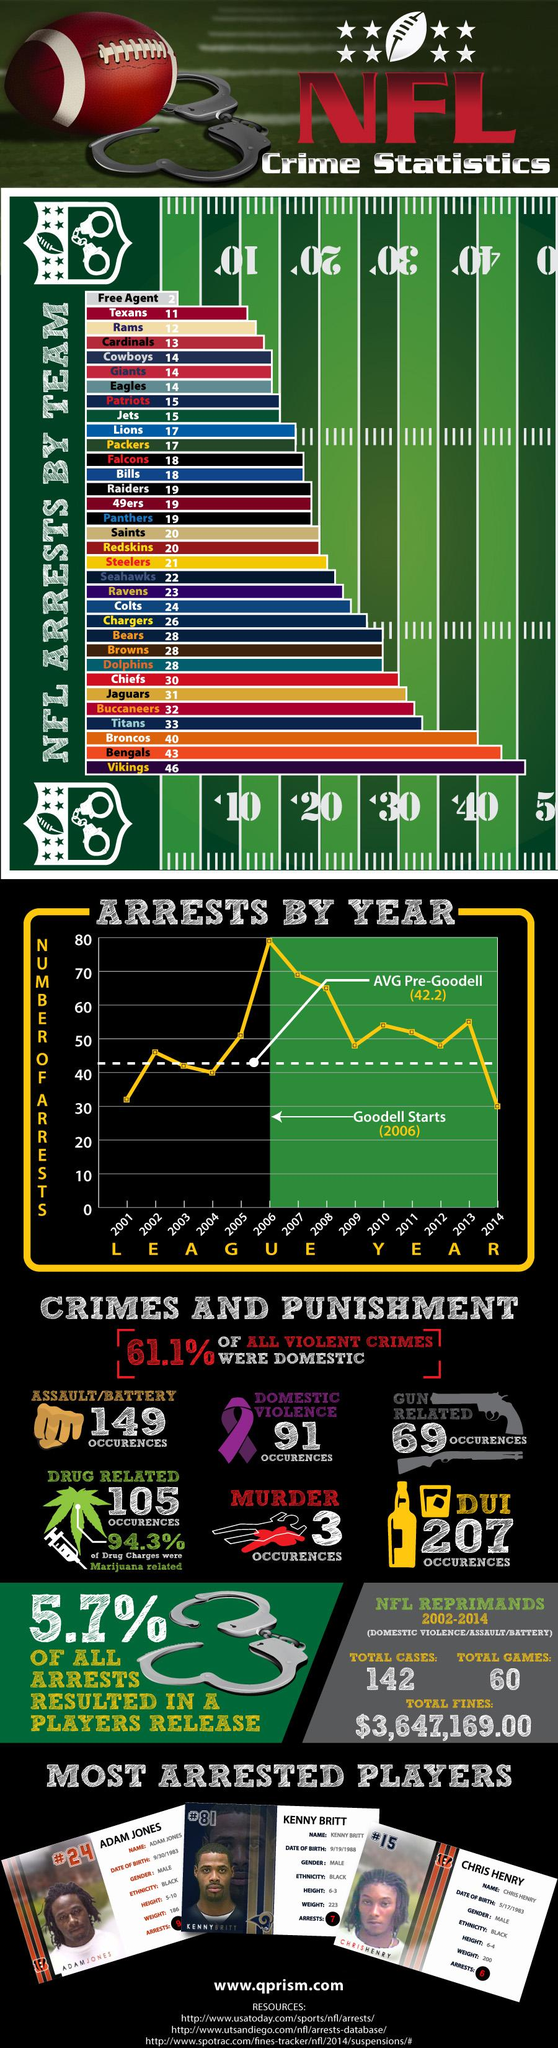Specify some key components in this picture. In the year 2006, the highest number of NFL arrests has been recorded since 2000. The player with the most arrests in the NFL since 2000 is Adrian Arrington. Chris Henry has been arrested six times. Since 2000, the Minnesota Vikings have reported the highest number of arrests among all NFL teams. The main reason for NFL players' arrests is DUI. 